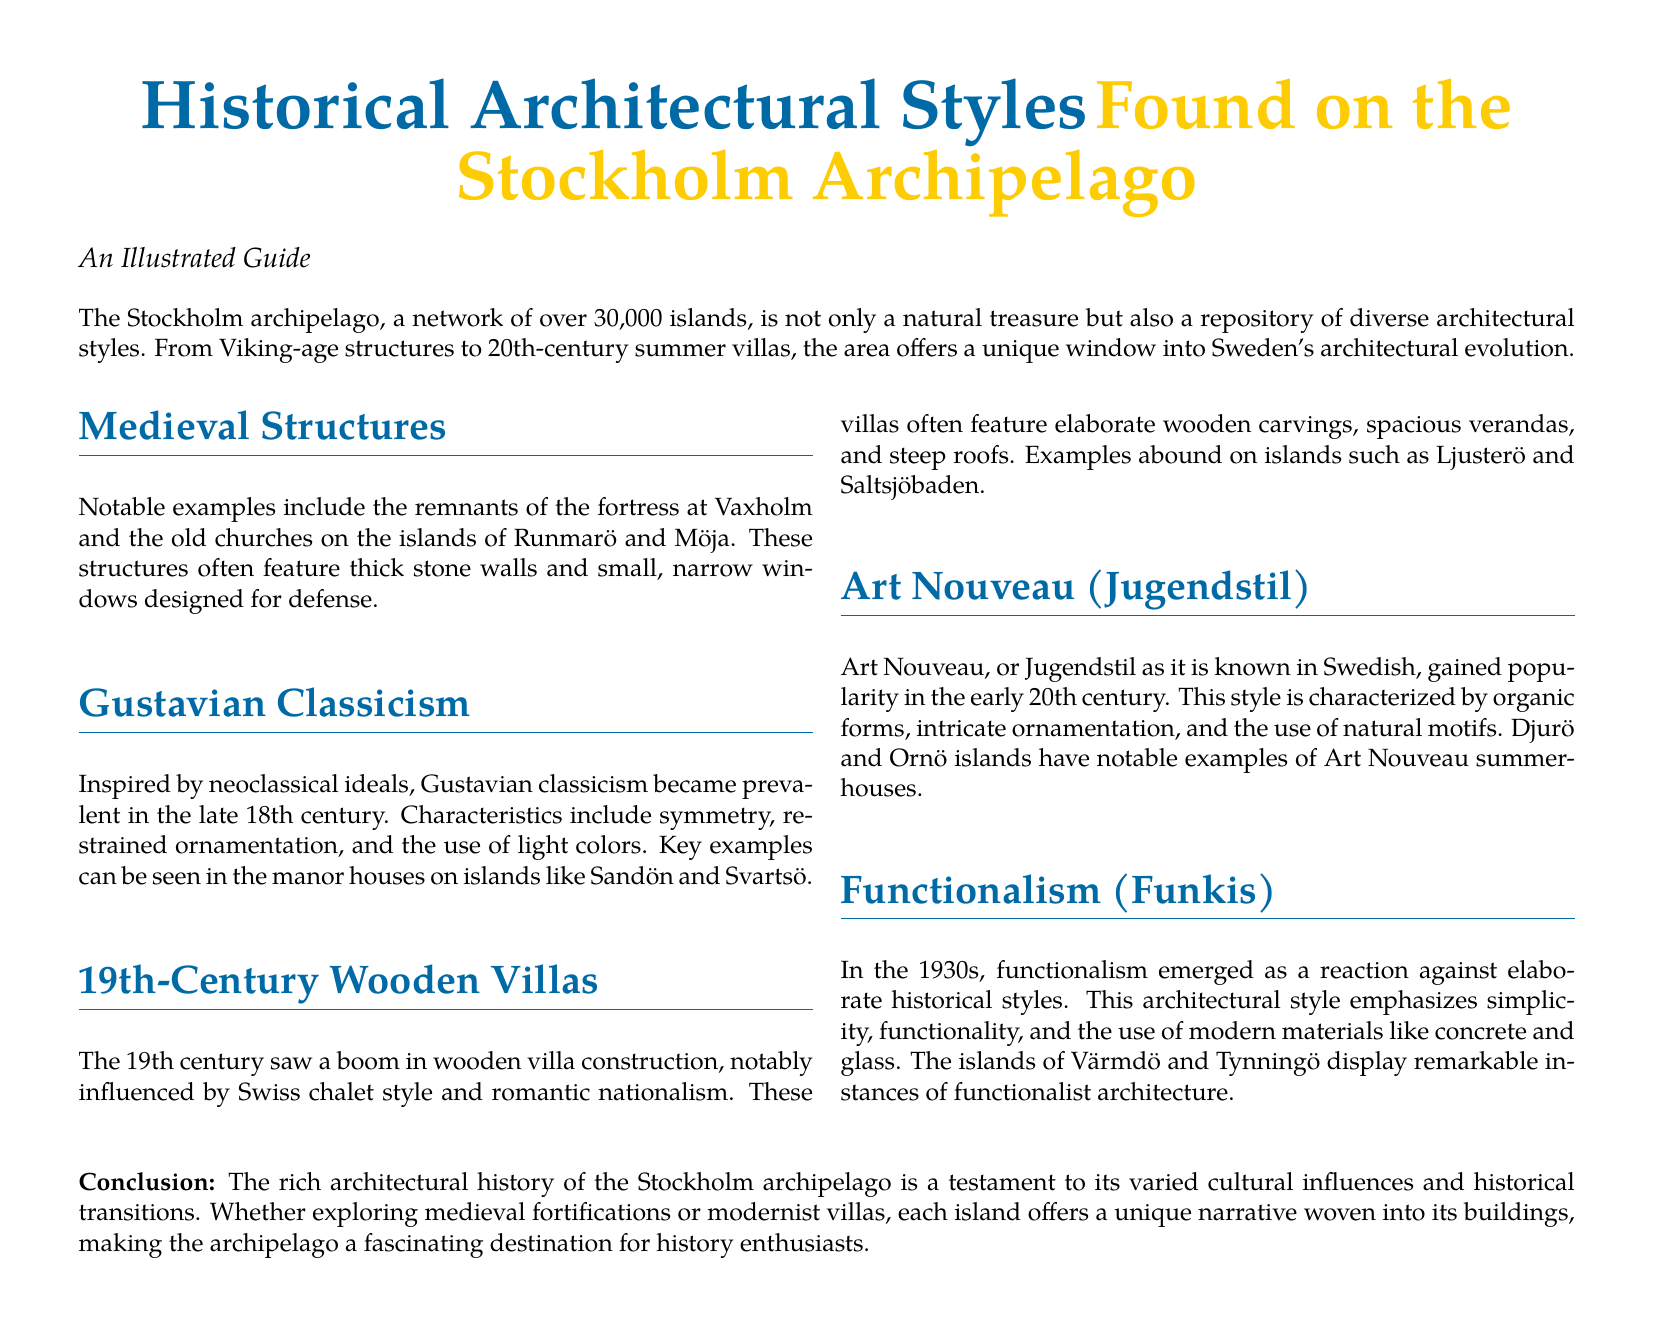What architectural style became prevalent in the late 18th century? The document states that Gustavian classicism became prevalent in the late 18th century.
Answer: Gustavian classicism Which islands feature notable examples of medieval structures? The document mentions the islands of Runmarö and Möja as having old churches that are medieval structures.
Answer: Runmarö and Möja What is a characteristic of Art Nouveau style? The document describes Art Nouveau as characterized by organic forms and intricate ornamentation.
Answer: Organic forms In what decade did functionalism emerge? The document indicates that functionalism emerged in the 1930s.
Answer: 1930s Which island is mentioned for having examples of 19th-century wooden villas? The document specifies that islands such as Ljusterö and Saltsjöbaden have examples of 19th-century wooden villas.
Answer: Ljusterö and Saltsjöbaden What materials are emphasized in functionalist architecture? The document highlights that modern materials like concrete and glass are used in functionalist architecture.
Answer: Concrete and glass What style features elaborate wooden carvings and spacious verandas? The document describes the 19th-century wooden villas as featuring elaborate wooden carvings and spacious verandas.
Answer: 19th-century wooden villas What is the conclusion of the document about the architectural history of the Stockholm archipelago? The conclusion states that the architectural history is a testament to its varied cultural influences and historical transitions.
Answer: Varied cultural influences and historical transitions 